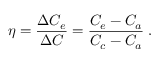Convert formula to latex. <formula><loc_0><loc_0><loc_500><loc_500>\eta = \frac { \Delta C _ { e } } { \Delta C } = \frac { C _ { e } - C _ { a } } { { C _ { c } } - C _ { a } } \, .</formula> 